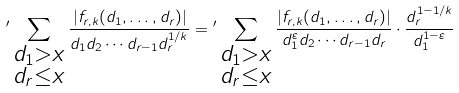Convert formula to latex. <formula><loc_0><loc_0><loc_500><loc_500>{ ^ { \prime } } \sum _ { \substack { d _ { 1 } > x \\ d _ { r } \leq x } } \frac { | f _ { r , k } ( d _ { 1 } , \dots , d _ { r } ) | } { d _ { 1 } d _ { 2 } \cdots d _ { r - 1 } d _ { r } ^ { 1 / k } } = { ^ { \prime } } \sum _ { \substack { d _ { 1 } > x \\ d _ { r } \leq x } } \frac { | f _ { r , k } ( d _ { 1 } , \dots , d _ { r } ) | } { d _ { 1 } ^ { \varepsilon } d _ { 2 } \cdots d _ { r - 1 } d _ { r } } \cdot \frac { d _ { r } ^ { 1 - 1 / k } } { d _ { 1 } ^ { 1 - \varepsilon } }</formula> 